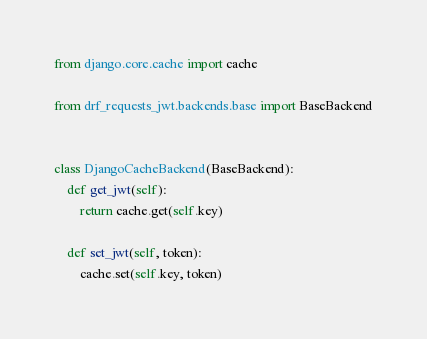Convert code to text. <code><loc_0><loc_0><loc_500><loc_500><_Python_>from django.core.cache import cache

from drf_requests_jwt.backends.base import BaseBackend


class DjangoCacheBackend(BaseBackend):
    def get_jwt(self):
        return cache.get(self.key)

    def set_jwt(self, token):
        cache.set(self.key, token)
</code> 